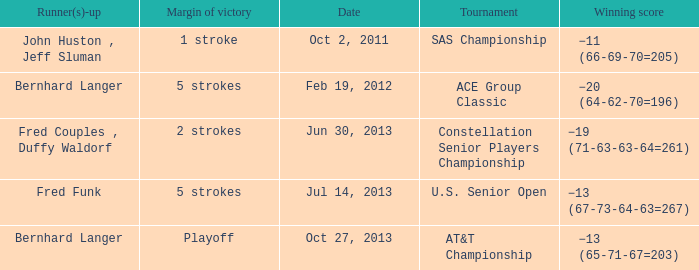Who's the Runner(s)-up with a Winning score of −19 (71-63-63-64=261)? Fred Couples , Duffy Waldorf. 